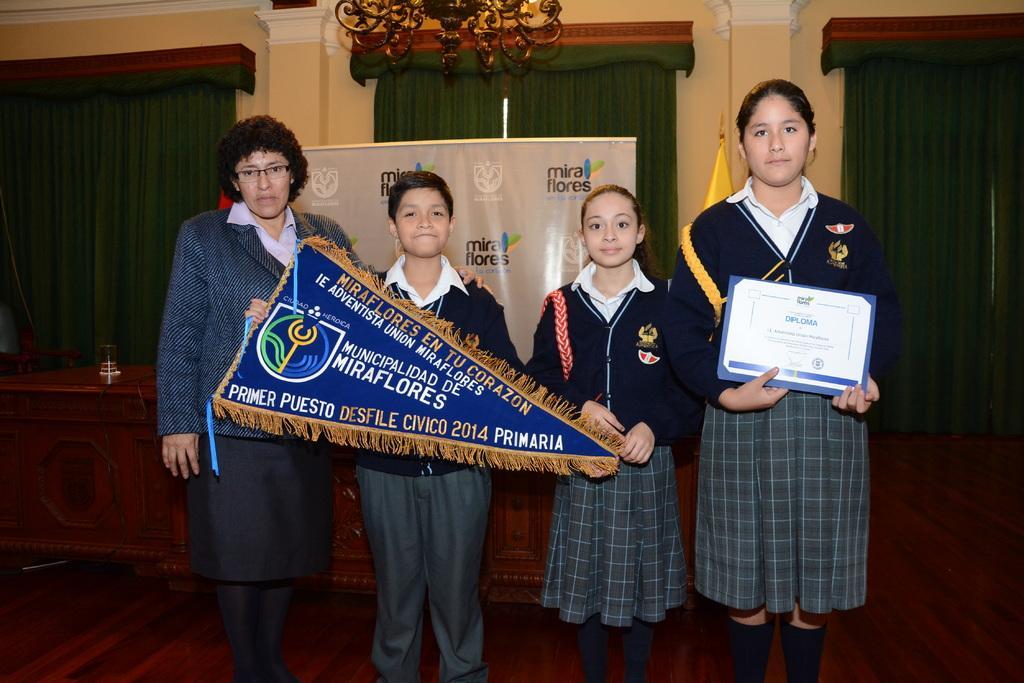How would you summarize this image in a sentence or two? This is an inside view of a room. Here I can see four people standing, holding certificate and a banner in their hands, smiling and giving pose for the picture. At the back of these people there is a table and there is a banner on which I can see some text. In the background and there are few curtains to the wall. At the top of the image there is a chandelier. At the bottom, I can see the floor. 